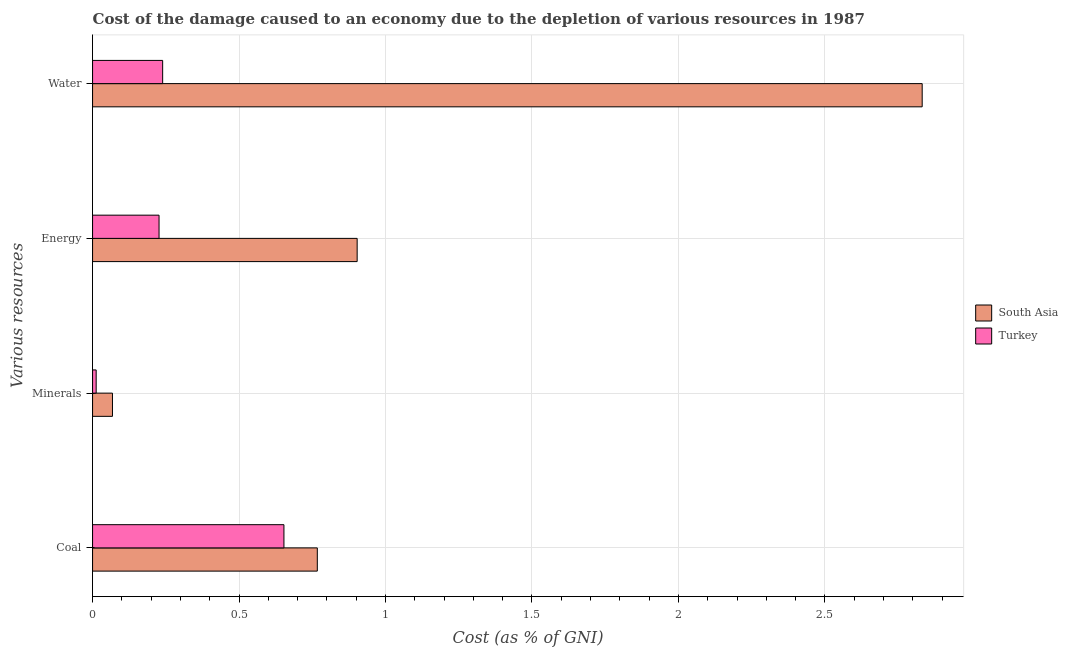How many different coloured bars are there?
Your answer should be compact. 2. Are the number of bars per tick equal to the number of legend labels?
Offer a terse response. Yes. How many bars are there on the 3rd tick from the top?
Make the answer very short. 2. What is the label of the 4th group of bars from the top?
Offer a very short reply. Coal. What is the cost of damage due to depletion of energy in South Asia?
Your response must be concise. 0.9. Across all countries, what is the maximum cost of damage due to depletion of minerals?
Offer a very short reply. 0.07. Across all countries, what is the minimum cost of damage due to depletion of water?
Offer a very short reply. 0.24. In which country was the cost of damage due to depletion of energy minimum?
Provide a short and direct response. Turkey. What is the total cost of damage due to depletion of minerals in the graph?
Ensure brevity in your answer.  0.08. What is the difference between the cost of damage due to depletion of minerals in South Asia and that in Turkey?
Ensure brevity in your answer.  0.06. What is the difference between the cost of damage due to depletion of energy in Turkey and the cost of damage due to depletion of coal in South Asia?
Your answer should be compact. -0.54. What is the average cost of damage due to depletion of coal per country?
Give a very brief answer. 0.71. What is the difference between the cost of damage due to depletion of minerals and cost of damage due to depletion of water in Turkey?
Your answer should be very brief. -0.23. What is the ratio of the cost of damage due to depletion of water in South Asia to that in Turkey?
Make the answer very short. 11.84. Is the difference between the cost of damage due to depletion of water in South Asia and Turkey greater than the difference between the cost of damage due to depletion of minerals in South Asia and Turkey?
Your response must be concise. Yes. What is the difference between the highest and the second highest cost of damage due to depletion of energy?
Ensure brevity in your answer.  0.68. What is the difference between the highest and the lowest cost of damage due to depletion of minerals?
Offer a very short reply. 0.06. In how many countries, is the cost of damage due to depletion of water greater than the average cost of damage due to depletion of water taken over all countries?
Your answer should be very brief. 1. Is the sum of the cost of damage due to depletion of minerals in South Asia and Turkey greater than the maximum cost of damage due to depletion of coal across all countries?
Ensure brevity in your answer.  No. What does the 1st bar from the bottom in Coal represents?
Make the answer very short. South Asia. How many countries are there in the graph?
Your response must be concise. 2. What is the difference between two consecutive major ticks on the X-axis?
Keep it short and to the point. 0.5. Does the graph contain any zero values?
Offer a terse response. No. What is the title of the graph?
Ensure brevity in your answer.  Cost of the damage caused to an economy due to the depletion of various resources in 1987 . Does "Tunisia" appear as one of the legend labels in the graph?
Offer a terse response. No. What is the label or title of the X-axis?
Ensure brevity in your answer.  Cost (as % of GNI). What is the label or title of the Y-axis?
Your answer should be compact. Various resources. What is the Cost (as % of GNI) of South Asia in Coal?
Provide a succinct answer. 0.77. What is the Cost (as % of GNI) in Turkey in Coal?
Keep it short and to the point. 0.65. What is the Cost (as % of GNI) in South Asia in Minerals?
Provide a succinct answer. 0.07. What is the Cost (as % of GNI) of Turkey in Minerals?
Your answer should be very brief. 0.01. What is the Cost (as % of GNI) in South Asia in Energy?
Make the answer very short. 0.9. What is the Cost (as % of GNI) in Turkey in Energy?
Give a very brief answer. 0.23. What is the Cost (as % of GNI) in South Asia in Water?
Provide a succinct answer. 2.83. What is the Cost (as % of GNI) of Turkey in Water?
Your answer should be compact. 0.24. Across all Various resources, what is the maximum Cost (as % of GNI) in South Asia?
Ensure brevity in your answer.  2.83. Across all Various resources, what is the maximum Cost (as % of GNI) in Turkey?
Ensure brevity in your answer.  0.65. Across all Various resources, what is the minimum Cost (as % of GNI) of South Asia?
Provide a short and direct response. 0.07. Across all Various resources, what is the minimum Cost (as % of GNI) in Turkey?
Your response must be concise. 0.01. What is the total Cost (as % of GNI) of South Asia in the graph?
Offer a very short reply. 4.57. What is the total Cost (as % of GNI) of Turkey in the graph?
Offer a terse response. 1.13. What is the difference between the Cost (as % of GNI) in South Asia in Coal and that in Minerals?
Make the answer very short. 0.7. What is the difference between the Cost (as % of GNI) in Turkey in Coal and that in Minerals?
Provide a succinct answer. 0.64. What is the difference between the Cost (as % of GNI) in South Asia in Coal and that in Energy?
Provide a short and direct response. -0.14. What is the difference between the Cost (as % of GNI) in Turkey in Coal and that in Energy?
Offer a terse response. 0.43. What is the difference between the Cost (as % of GNI) of South Asia in Coal and that in Water?
Offer a terse response. -2.06. What is the difference between the Cost (as % of GNI) in Turkey in Coal and that in Water?
Your answer should be compact. 0.41. What is the difference between the Cost (as % of GNI) in South Asia in Minerals and that in Energy?
Make the answer very short. -0.84. What is the difference between the Cost (as % of GNI) of Turkey in Minerals and that in Energy?
Keep it short and to the point. -0.21. What is the difference between the Cost (as % of GNI) in South Asia in Minerals and that in Water?
Offer a very short reply. -2.76. What is the difference between the Cost (as % of GNI) in Turkey in Minerals and that in Water?
Provide a succinct answer. -0.23. What is the difference between the Cost (as % of GNI) of South Asia in Energy and that in Water?
Make the answer very short. -1.93. What is the difference between the Cost (as % of GNI) in Turkey in Energy and that in Water?
Your answer should be very brief. -0.01. What is the difference between the Cost (as % of GNI) of South Asia in Coal and the Cost (as % of GNI) of Turkey in Minerals?
Make the answer very short. 0.75. What is the difference between the Cost (as % of GNI) in South Asia in Coal and the Cost (as % of GNI) in Turkey in Energy?
Your answer should be very brief. 0.54. What is the difference between the Cost (as % of GNI) in South Asia in Coal and the Cost (as % of GNI) in Turkey in Water?
Your answer should be compact. 0.53. What is the difference between the Cost (as % of GNI) in South Asia in Minerals and the Cost (as % of GNI) in Turkey in Energy?
Ensure brevity in your answer.  -0.16. What is the difference between the Cost (as % of GNI) of South Asia in Minerals and the Cost (as % of GNI) of Turkey in Water?
Offer a very short reply. -0.17. What is the difference between the Cost (as % of GNI) in South Asia in Energy and the Cost (as % of GNI) in Turkey in Water?
Offer a very short reply. 0.66. What is the average Cost (as % of GNI) of South Asia per Various resources?
Give a very brief answer. 1.14. What is the average Cost (as % of GNI) in Turkey per Various resources?
Provide a short and direct response. 0.28. What is the difference between the Cost (as % of GNI) in South Asia and Cost (as % of GNI) in Turkey in Coal?
Make the answer very short. 0.11. What is the difference between the Cost (as % of GNI) in South Asia and Cost (as % of GNI) in Turkey in Minerals?
Provide a succinct answer. 0.06. What is the difference between the Cost (as % of GNI) in South Asia and Cost (as % of GNI) in Turkey in Energy?
Provide a succinct answer. 0.68. What is the difference between the Cost (as % of GNI) in South Asia and Cost (as % of GNI) in Turkey in Water?
Give a very brief answer. 2.59. What is the ratio of the Cost (as % of GNI) of South Asia in Coal to that in Minerals?
Make the answer very short. 11.29. What is the ratio of the Cost (as % of GNI) of Turkey in Coal to that in Minerals?
Make the answer very short. 53.01. What is the ratio of the Cost (as % of GNI) in South Asia in Coal to that in Energy?
Keep it short and to the point. 0.85. What is the ratio of the Cost (as % of GNI) in Turkey in Coal to that in Energy?
Your answer should be very brief. 2.88. What is the ratio of the Cost (as % of GNI) in South Asia in Coal to that in Water?
Provide a succinct answer. 0.27. What is the ratio of the Cost (as % of GNI) of Turkey in Coal to that in Water?
Your response must be concise. 2.73. What is the ratio of the Cost (as % of GNI) in South Asia in Minerals to that in Energy?
Offer a very short reply. 0.08. What is the ratio of the Cost (as % of GNI) in Turkey in Minerals to that in Energy?
Your response must be concise. 0.05. What is the ratio of the Cost (as % of GNI) in South Asia in Minerals to that in Water?
Your answer should be very brief. 0.02. What is the ratio of the Cost (as % of GNI) in Turkey in Minerals to that in Water?
Offer a terse response. 0.05. What is the ratio of the Cost (as % of GNI) in South Asia in Energy to that in Water?
Your answer should be compact. 0.32. What is the ratio of the Cost (as % of GNI) in Turkey in Energy to that in Water?
Offer a terse response. 0.95. What is the difference between the highest and the second highest Cost (as % of GNI) of South Asia?
Offer a terse response. 1.93. What is the difference between the highest and the second highest Cost (as % of GNI) of Turkey?
Provide a succinct answer. 0.41. What is the difference between the highest and the lowest Cost (as % of GNI) in South Asia?
Provide a short and direct response. 2.76. What is the difference between the highest and the lowest Cost (as % of GNI) in Turkey?
Provide a short and direct response. 0.64. 